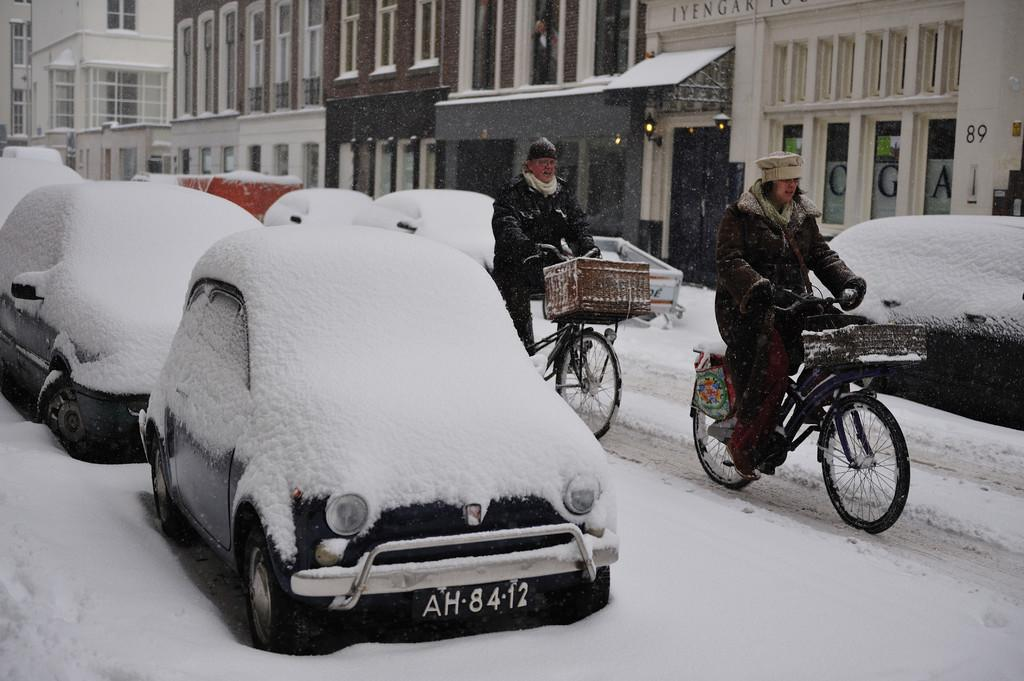What are the two persons doing in the image? The two persons are riding bicycles. How are the cars in the image affected by the weather? The cars are covered with snow. What can be seen in the background of the image? There are buildings near the cars. Where is the beggar sitting near the tub in the image? There is no beggar or tub present in the image. What type of hydrant is visible in the image? There is no hydrant visible in the image. 